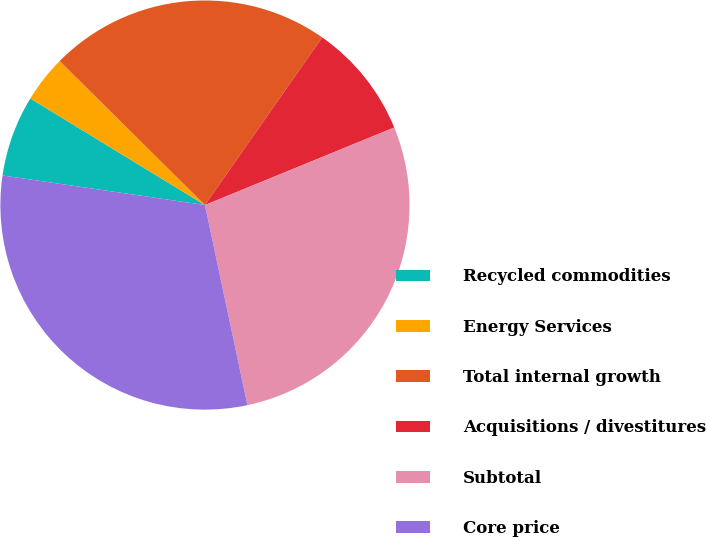Convert chart. <chart><loc_0><loc_0><loc_500><loc_500><pie_chart><fcel>Recycled commodities<fcel>Energy Services<fcel>Total internal growth<fcel>Acquisitions / divestitures<fcel>Subtotal<fcel>Core price<nl><fcel>6.41%<fcel>3.71%<fcel>22.28%<fcel>9.1%<fcel>27.86%<fcel>30.64%<nl></chart> 